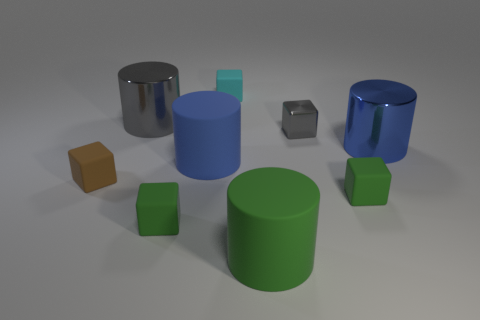Subtract all gray cylinders. Subtract all cyan balls. How many cylinders are left? 3 Add 1 small gray cubes. How many objects exist? 10 Subtract all blocks. How many objects are left? 4 Subtract all small cyan matte blocks. Subtract all big brown metal cubes. How many objects are left? 8 Add 4 brown matte things. How many brown matte things are left? 5 Add 5 rubber blocks. How many rubber blocks exist? 9 Subtract 0 purple balls. How many objects are left? 9 